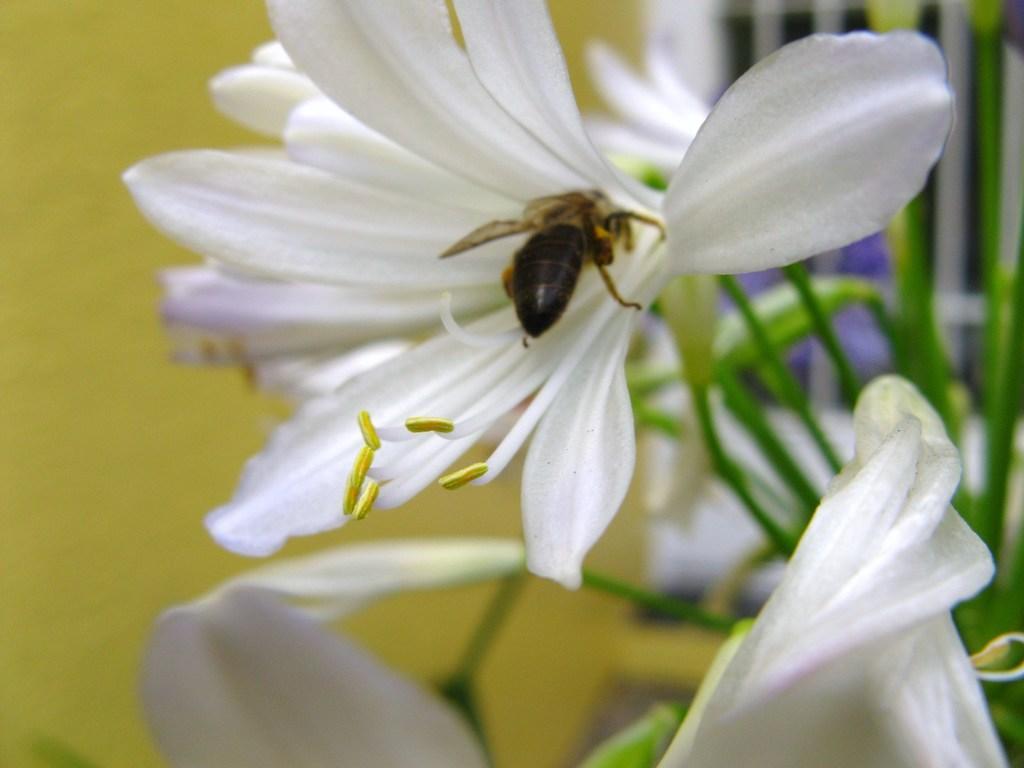Could you give a brief overview of what you see in this image? In this image we can see a bee on the flower. 